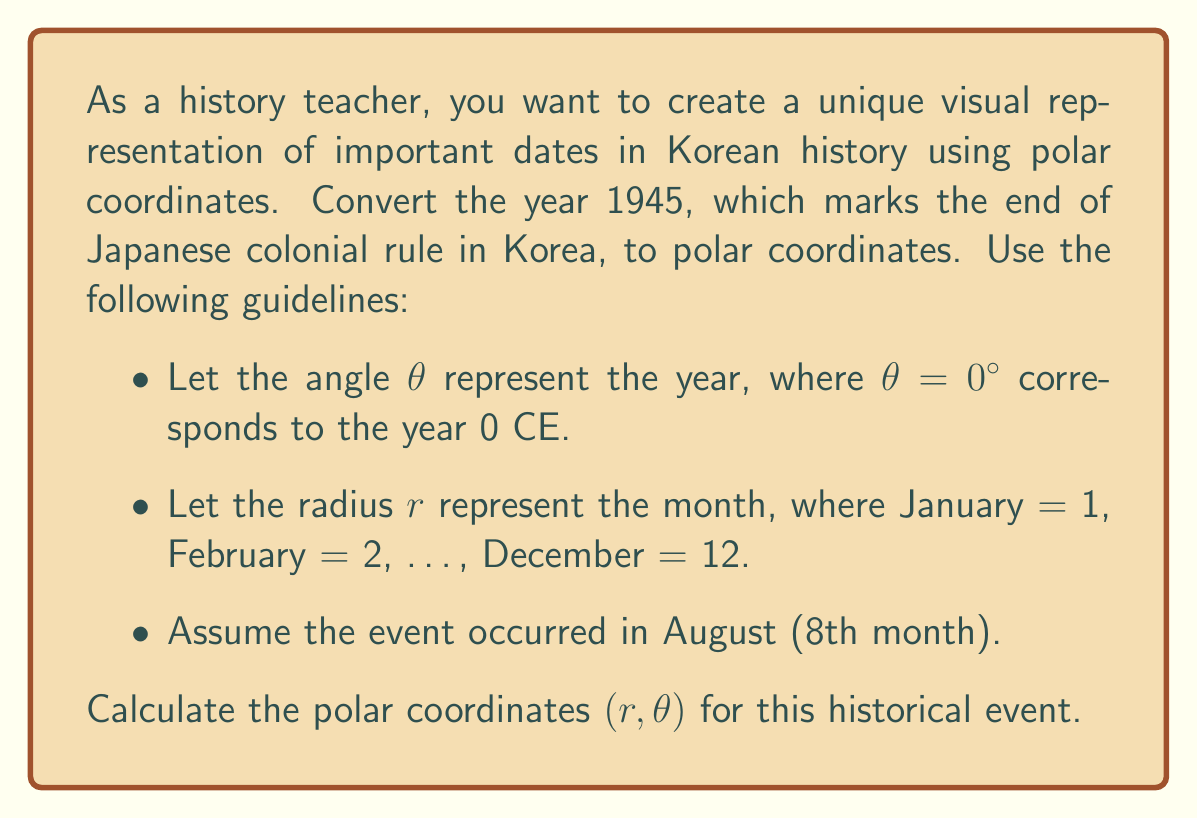Give your solution to this math problem. To convert the year 1945 and month 8 (August) to polar coordinates, we need to follow these steps:

1. Calculate $\theta$:
   - Each year corresponds to 360° ÷ 100 = 3.6° (assuming we want to represent 100 years in a full circle)
   - $\theta = 1945 \times 3.6° = 7002°$
   
   We can simplify this by taking the modulo with 360°:
   $$\theta = 7002° \bmod 360° = 162°$$

2. Calculate $r$:
   - The radius $r$ directly corresponds to the month number
   - August is the 8th month, so $r = 8$

Therefore, the polar coordinates for the end of Japanese colonial rule in Korea (August 1945) are:

$$(r, \theta) = (8, 162°)$$

This representation allows for a visual depiction where the angle represents the year (with each full rotation representing a century) and the radius represents the month of the year.
Answer: $(8, 162°)$ 